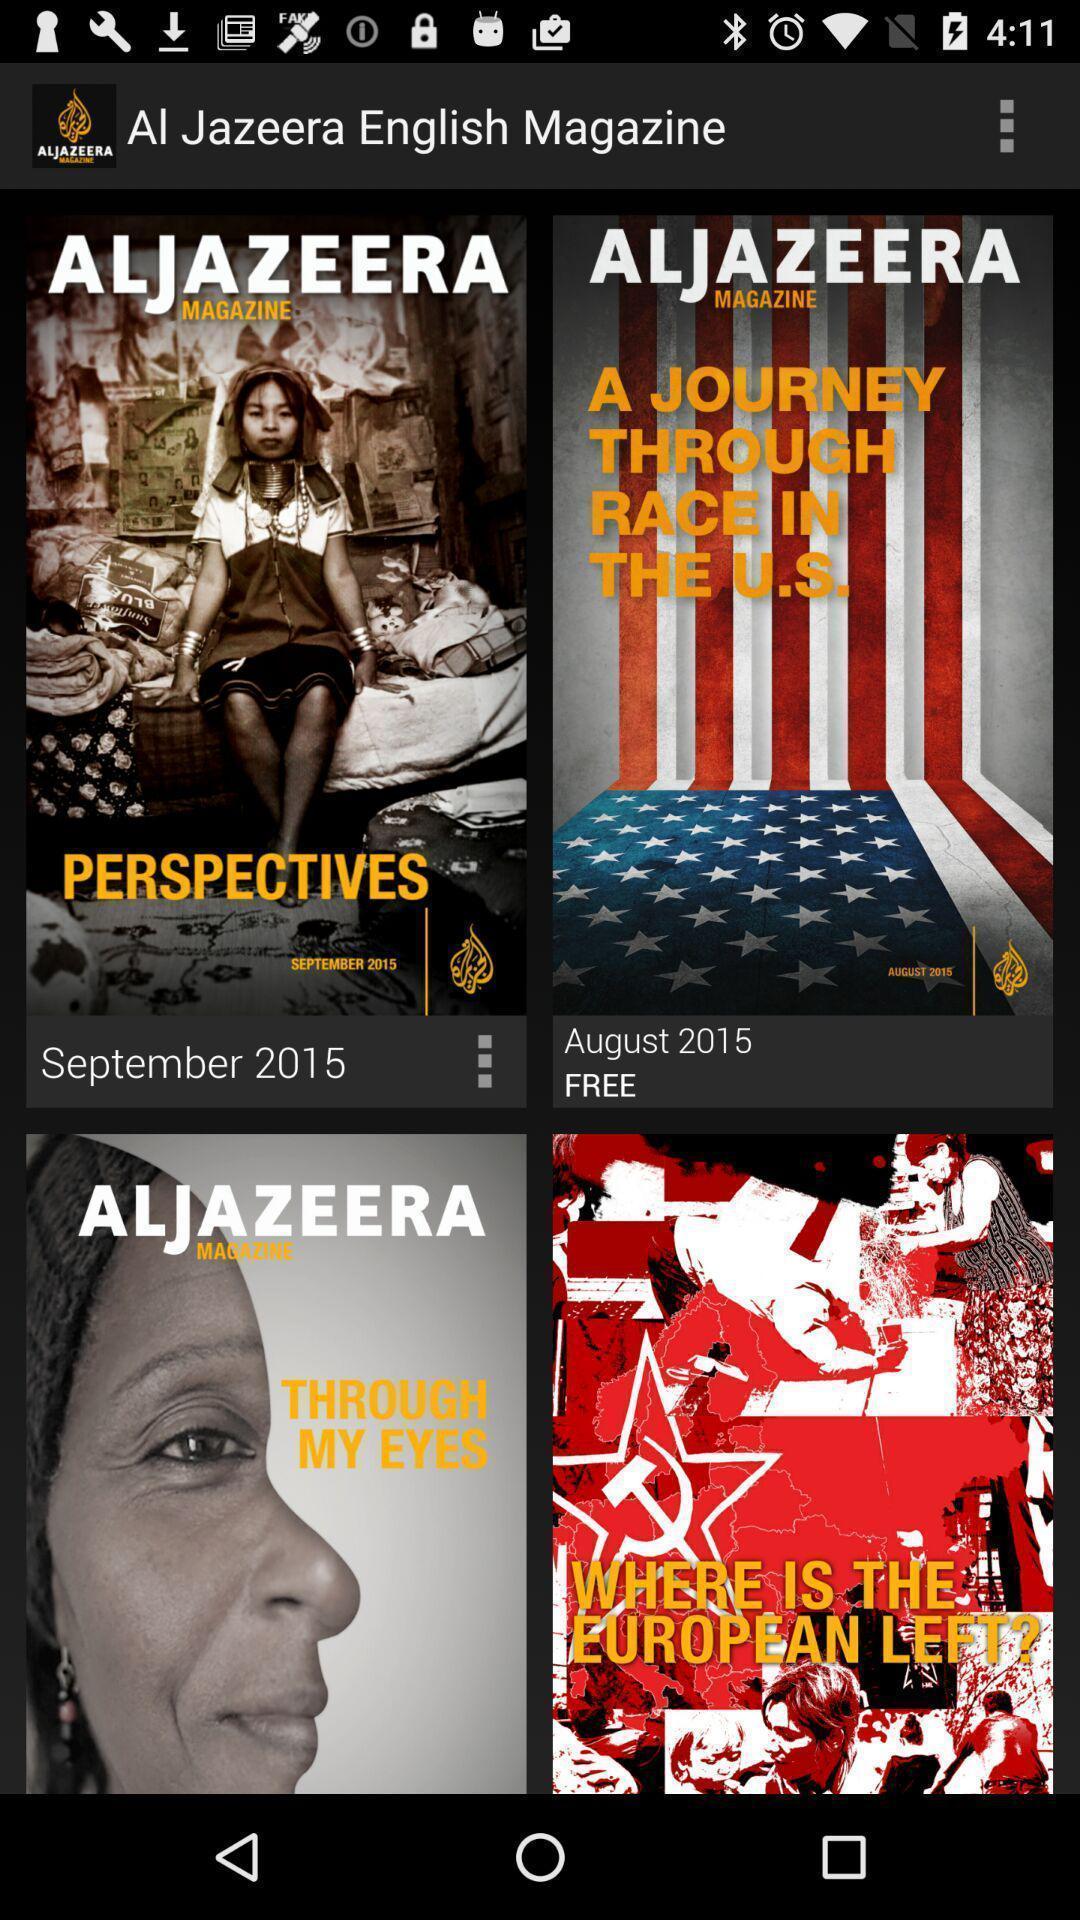Summarize the main components in this picture. Page displaying multiple magazines. 